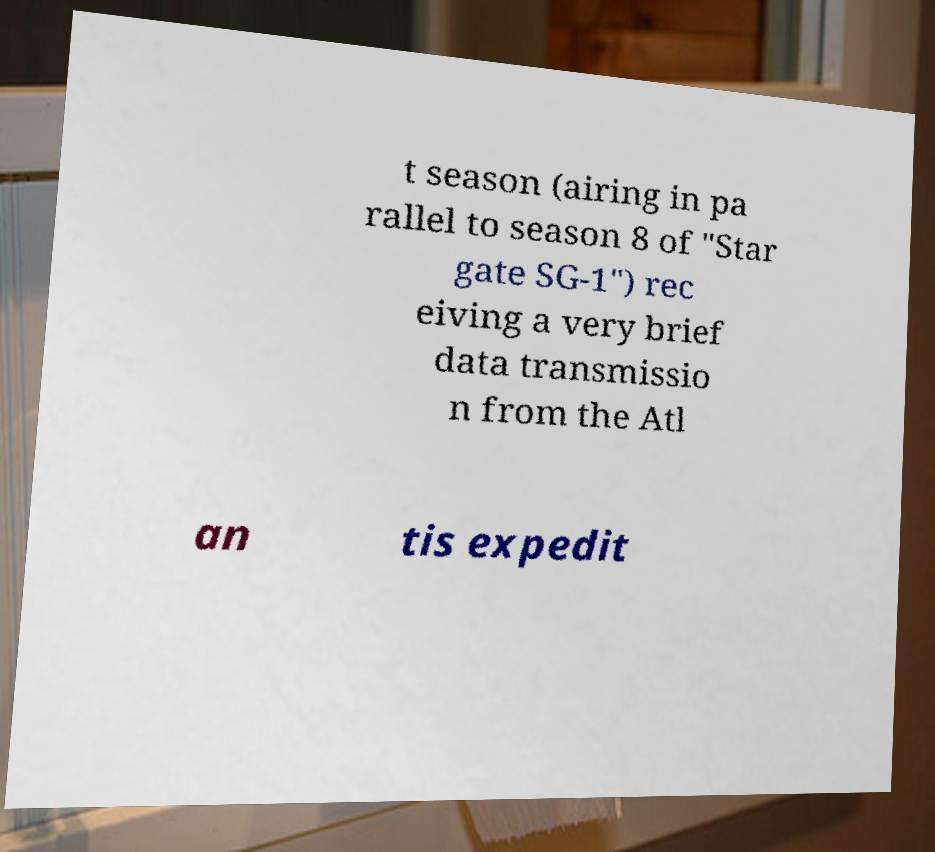Can you read and provide the text displayed in the image?This photo seems to have some interesting text. Can you extract and type it out for me? t season (airing in pa rallel to season 8 of "Star gate SG-1") rec eiving a very brief data transmissio n from the Atl an tis expedit 